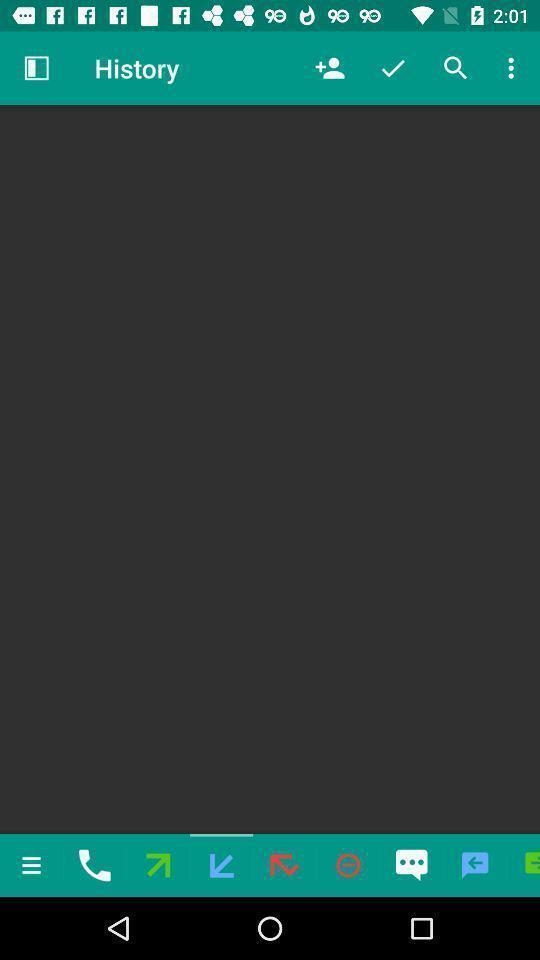Summarize the main components in this picture. Page of the history in the app. 